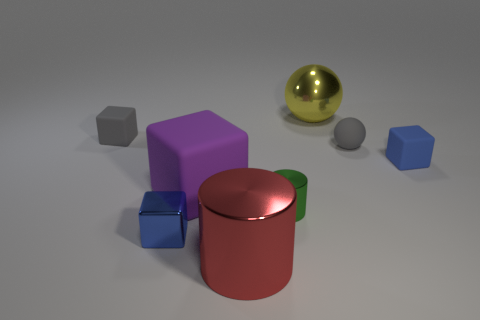Can you infer any relationship between the spatial arrangement of these objects? Analyzing the spatial arrangement, it seems that there is a deliberate effort to create balance and contrast in the placement of the objects. The central objects – the purple cube and the red cylinder – anchor the composition, while the surrounding smaller items, like the blue and gray cubes and the gold and gray spheres, seem to orbit around them or array in a way that creates visual harmony and contrast. This could suggest a conceptual relationship where the core objects represent central themes or institutions, with the other elements representing varying perspectives or roles that revolve around or support the central themes. 